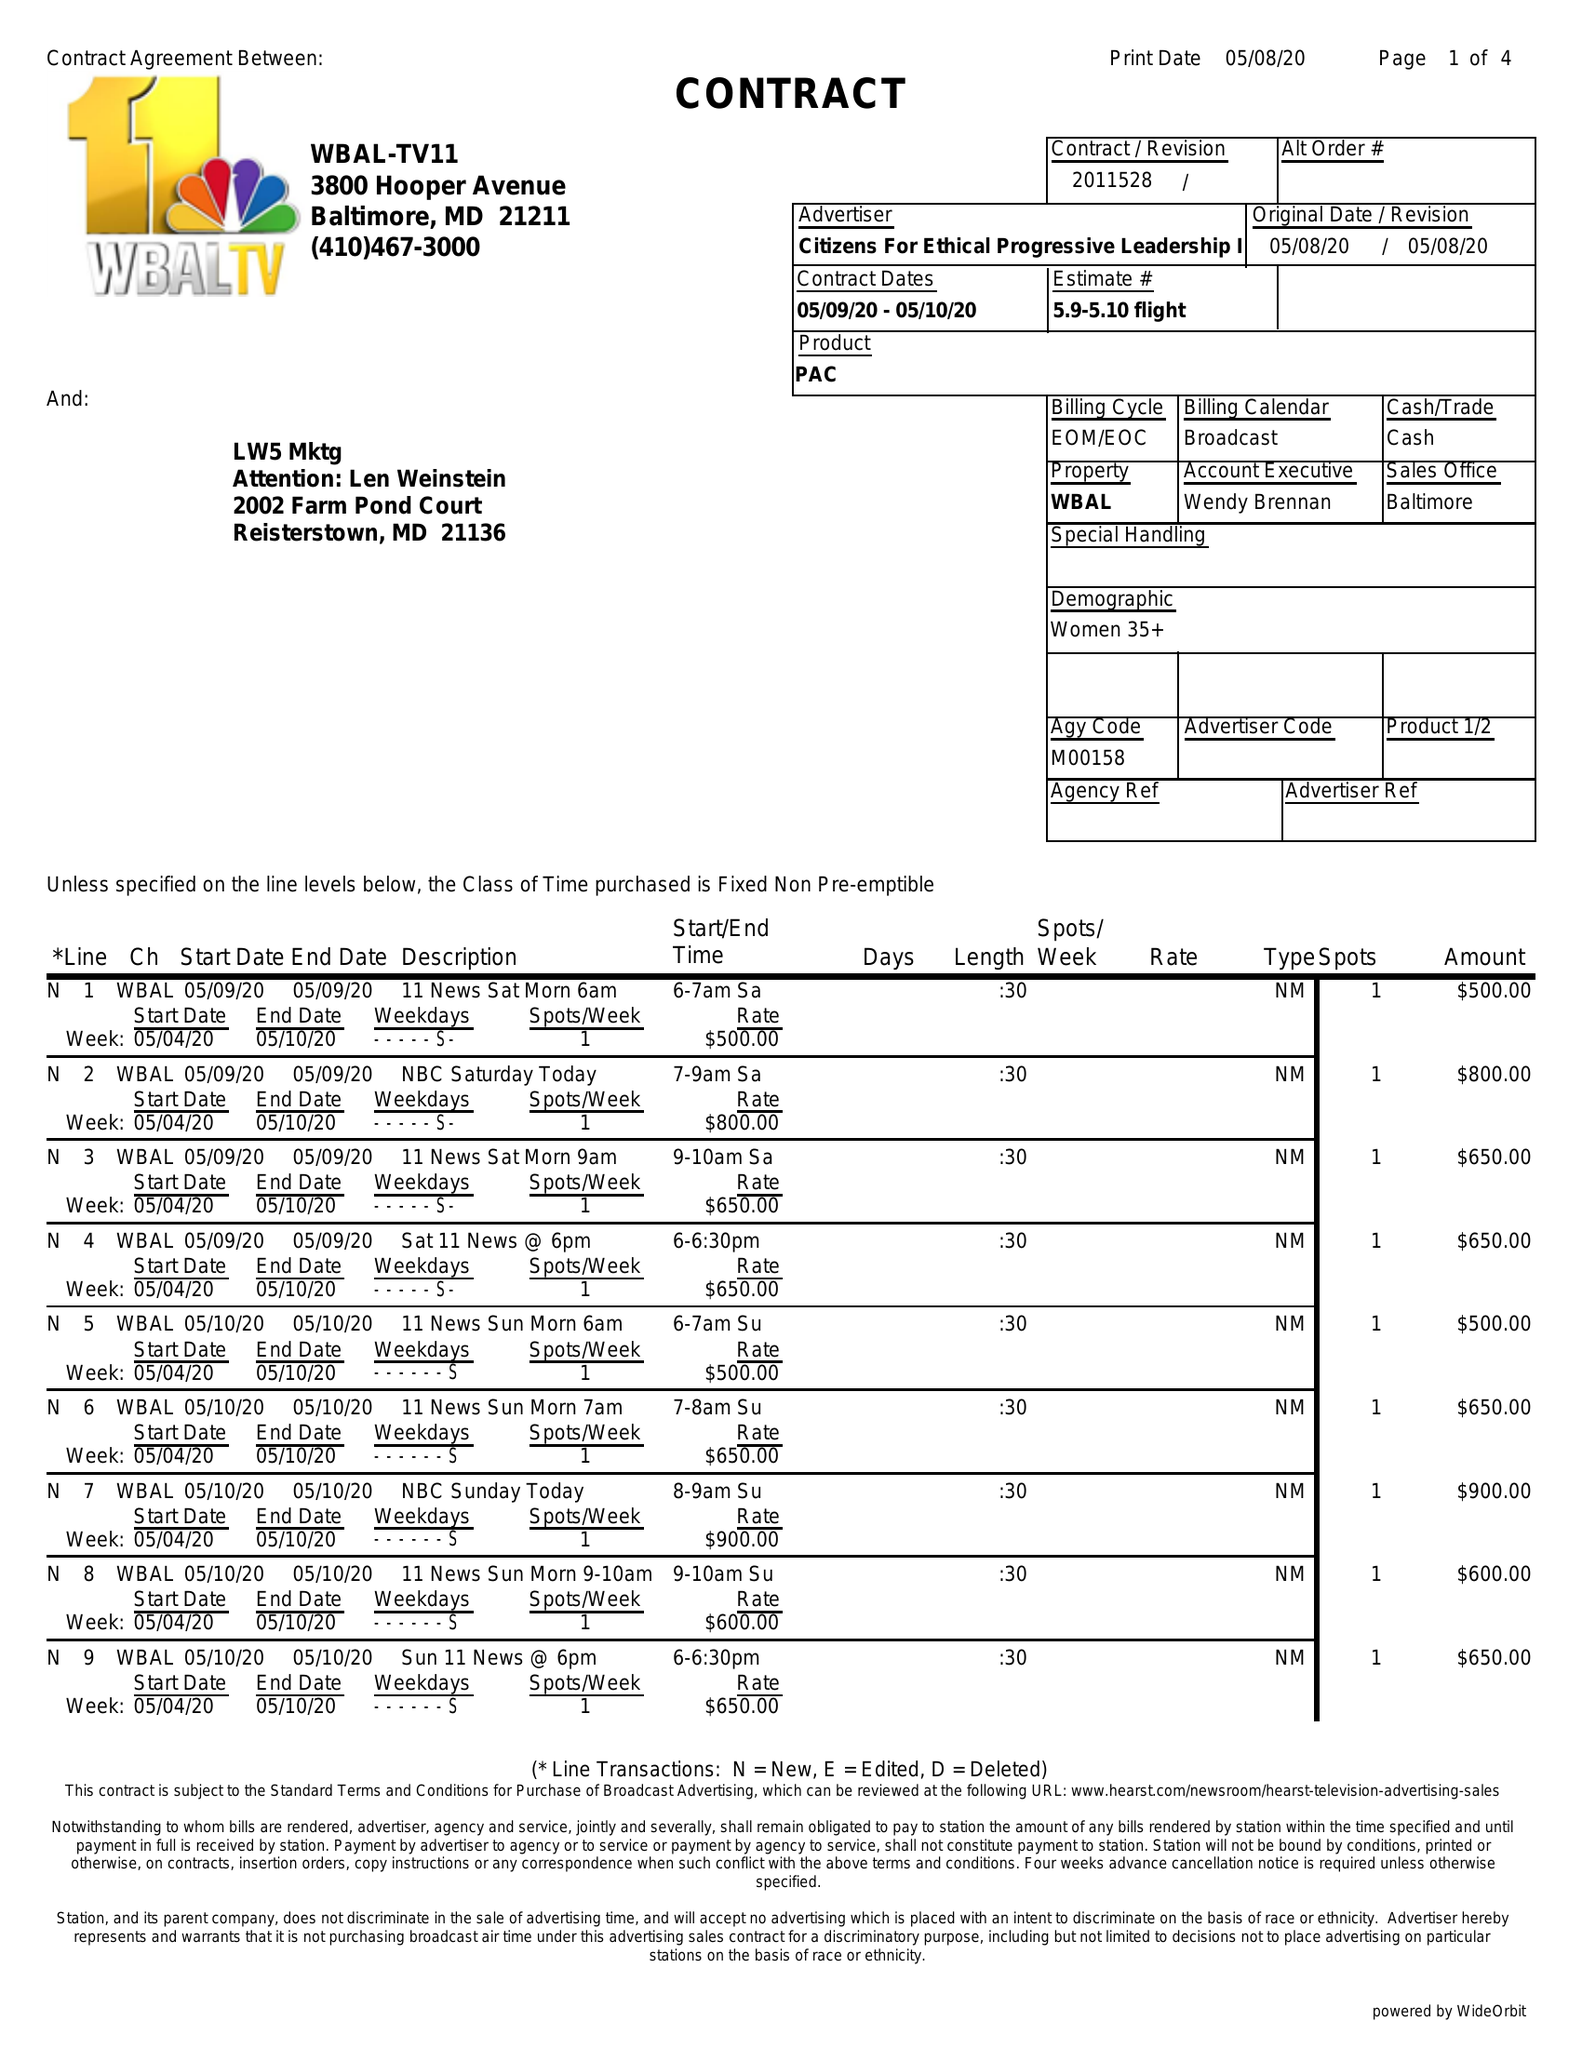What is the value for the contract_num?
Answer the question using a single word or phrase. 2011528 